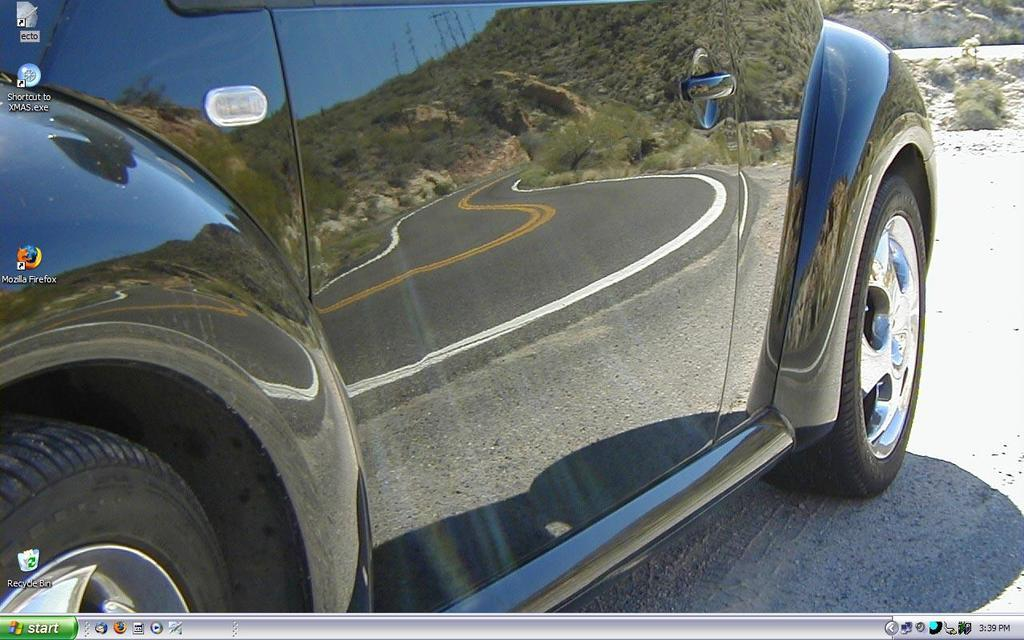What is the image of on the computer? The image is a wallpaper of a computer. What can be seen in the wallpaper? There is a car in the image. Where is the car located in the wallpaper? The car is on a road in the image. What direction is the needle pointing in the image? There is no needle present in the image. Is there a camp visible in the image? No, there is no camp visible in the image; it only features a car on a road. 